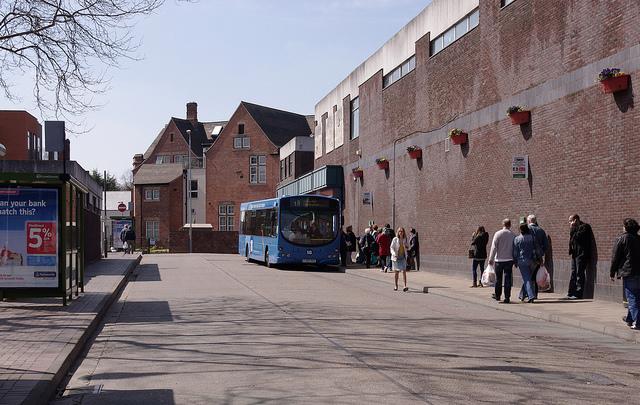What are the people waiting for?
Answer briefly. Bus. What color is the bus?
Quick response, please. Blue. What color is the truck?
Quick response, please. Blue. Is it raining?
Answer briefly. No. What color is the photo?
Give a very brief answer. Brown. 